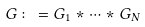Convert formula to latex. <formula><loc_0><loc_0><loc_500><loc_500>G \colon = G _ { 1 } * \cdots * G _ { N }</formula> 